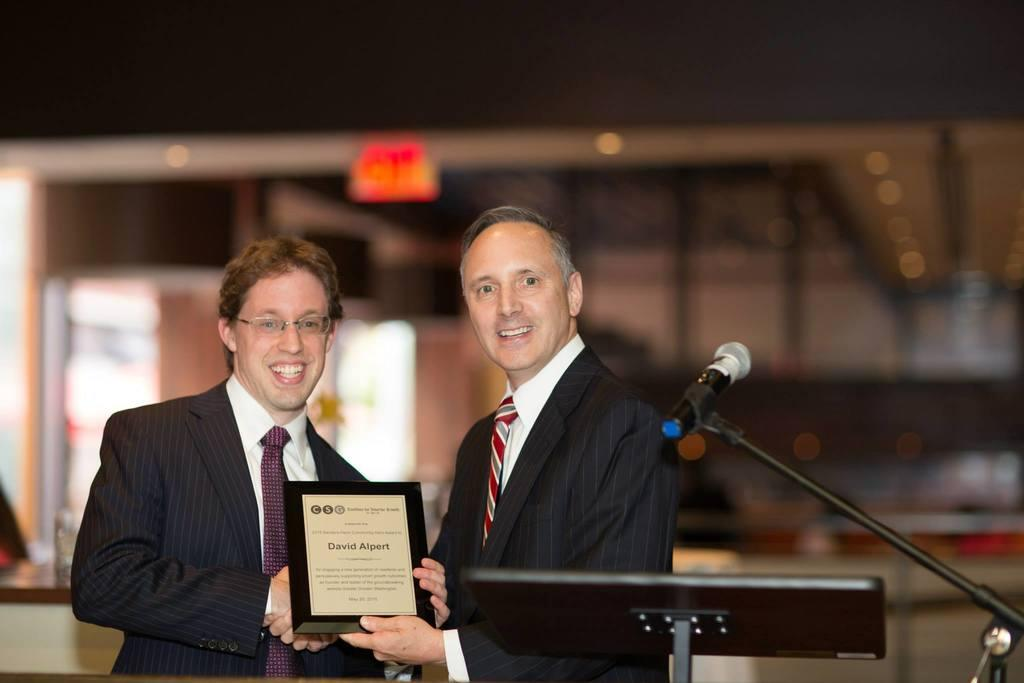How many people are in the image? There are two men in the image. What are the men holding in the image? The men are holding a frame. What is the facial expression of the men in the image? The men are smiling. What other object can be seen in the image? There is a microphone (mike) in the image. Can you describe the background of the image? The background of the image is blurred. What type of cakes are the men jumping over in the image? There are no cakes or jumping activities present in the image. 